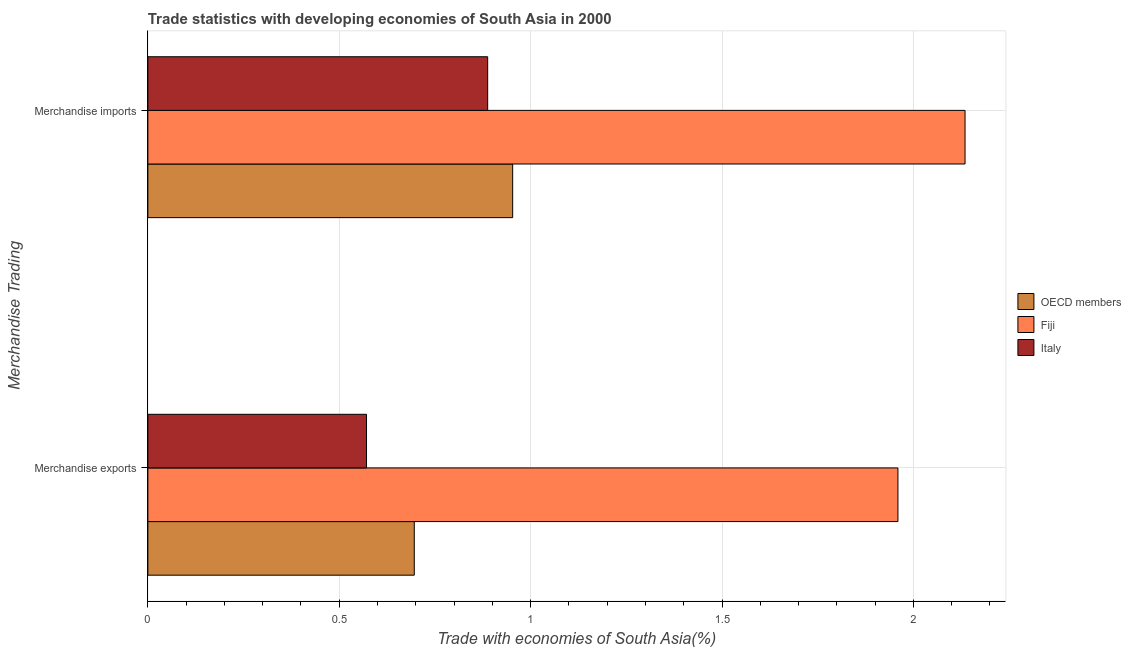How many groups of bars are there?
Give a very brief answer. 2. Are the number of bars per tick equal to the number of legend labels?
Give a very brief answer. Yes. Are the number of bars on each tick of the Y-axis equal?
Ensure brevity in your answer.  Yes. What is the label of the 2nd group of bars from the top?
Make the answer very short. Merchandise exports. What is the merchandise exports in Fiji?
Ensure brevity in your answer.  1.96. Across all countries, what is the maximum merchandise imports?
Offer a terse response. 2.13. Across all countries, what is the minimum merchandise exports?
Offer a very short reply. 0.57. In which country was the merchandise imports maximum?
Provide a succinct answer. Fiji. In which country was the merchandise imports minimum?
Provide a succinct answer. Italy. What is the total merchandise imports in the graph?
Your response must be concise. 3.98. What is the difference between the merchandise imports in Italy and that in Fiji?
Offer a very short reply. -1.25. What is the difference between the merchandise exports in Italy and the merchandise imports in Fiji?
Keep it short and to the point. -1.56. What is the average merchandise exports per country?
Your answer should be very brief. 1.08. What is the difference between the merchandise imports and merchandise exports in Italy?
Your answer should be compact. 0.32. What is the ratio of the merchandise exports in OECD members to that in Fiji?
Your response must be concise. 0.36. Is the merchandise imports in Italy less than that in Fiji?
Offer a very short reply. Yes. In how many countries, is the merchandise imports greater than the average merchandise imports taken over all countries?
Your response must be concise. 1. What does the 1st bar from the bottom in Merchandise imports represents?
Make the answer very short. OECD members. How many countries are there in the graph?
Ensure brevity in your answer.  3. What is the difference between two consecutive major ticks on the X-axis?
Offer a terse response. 0.5. Are the values on the major ticks of X-axis written in scientific E-notation?
Ensure brevity in your answer.  No. Does the graph contain any zero values?
Keep it short and to the point. No. Does the graph contain grids?
Make the answer very short. Yes. Where does the legend appear in the graph?
Ensure brevity in your answer.  Center right. How many legend labels are there?
Your answer should be very brief. 3. What is the title of the graph?
Your answer should be compact. Trade statistics with developing economies of South Asia in 2000. Does "Mozambique" appear as one of the legend labels in the graph?
Your answer should be very brief. No. What is the label or title of the X-axis?
Give a very brief answer. Trade with economies of South Asia(%). What is the label or title of the Y-axis?
Provide a succinct answer. Merchandise Trading. What is the Trade with economies of South Asia(%) in OECD members in Merchandise exports?
Give a very brief answer. 0.7. What is the Trade with economies of South Asia(%) of Fiji in Merchandise exports?
Give a very brief answer. 1.96. What is the Trade with economies of South Asia(%) of Italy in Merchandise exports?
Your answer should be compact. 0.57. What is the Trade with economies of South Asia(%) in OECD members in Merchandise imports?
Your response must be concise. 0.95. What is the Trade with economies of South Asia(%) of Fiji in Merchandise imports?
Keep it short and to the point. 2.13. What is the Trade with economies of South Asia(%) in Italy in Merchandise imports?
Provide a short and direct response. 0.89. Across all Merchandise Trading, what is the maximum Trade with economies of South Asia(%) of OECD members?
Your answer should be compact. 0.95. Across all Merchandise Trading, what is the maximum Trade with economies of South Asia(%) in Fiji?
Offer a terse response. 2.13. Across all Merchandise Trading, what is the maximum Trade with economies of South Asia(%) in Italy?
Your answer should be very brief. 0.89. Across all Merchandise Trading, what is the minimum Trade with economies of South Asia(%) of OECD members?
Provide a short and direct response. 0.7. Across all Merchandise Trading, what is the minimum Trade with economies of South Asia(%) in Fiji?
Provide a succinct answer. 1.96. Across all Merchandise Trading, what is the minimum Trade with economies of South Asia(%) of Italy?
Make the answer very short. 0.57. What is the total Trade with economies of South Asia(%) of OECD members in the graph?
Make the answer very short. 1.65. What is the total Trade with economies of South Asia(%) in Fiji in the graph?
Give a very brief answer. 4.09. What is the total Trade with economies of South Asia(%) in Italy in the graph?
Offer a terse response. 1.46. What is the difference between the Trade with economies of South Asia(%) in OECD members in Merchandise exports and that in Merchandise imports?
Provide a succinct answer. -0.26. What is the difference between the Trade with economies of South Asia(%) of Fiji in Merchandise exports and that in Merchandise imports?
Your response must be concise. -0.18. What is the difference between the Trade with economies of South Asia(%) in Italy in Merchandise exports and that in Merchandise imports?
Ensure brevity in your answer.  -0.32. What is the difference between the Trade with economies of South Asia(%) of OECD members in Merchandise exports and the Trade with economies of South Asia(%) of Fiji in Merchandise imports?
Offer a terse response. -1.44. What is the difference between the Trade with economies of South Asia(%) in OECD members in Merchandise exports and the Trade with economies of South Asia(%) in Italy in Merchandise imports?
Ensure brevity in your answer.  -0.19. What is the difference between the Trade with economies of South Asia(%) of Fiji in Merchandise exports and the Trade with economies of South Asia(%) of Italy in Merchandise imports?
Ensure brevity in your answer.  1.07. What is the average Trade with economies of South Asia(%) in OECD members per Merchandise Trading?
Provide a short and direct response. 0.82. What is the average Trade with economies of South Asia(%) in Fiji per Merchandise Trading?
Provide a succinct answer. 2.05. What is the average Trade with economies of South Asia(%) in Italy per Merchandise Trading?
Your answer should be compact. 0.73. What is the difference between the Trade with economies of South Asia(%) of OECD members and Trade with economies of South Asia(%) of Fiji in Merchandise exports?
Provide a short and direct response. -1.26. What is the difference between the Trade with economies of South Asia(%) of OECD members and Trade with economies of South Asia(%) of Italy in Merchandise exports?
Make the answer very short. 0.12. What is the difference between the Trade with economies of South Asia(%) of Fiji and Trade with economies of South Asia(%) of Italy in Merchandise exports?
Give a very brief answer. 1.39. What is the difference between the Trade with economies of South Asia(%) in OECD members and Trade with economies of South Asia(%) in Fiji in Merchandise imports?
Your answer should be compact. -1.18. What is the difference between the Trade with economies of South Asia(%) in OECD members and Trade with economies of South Asia(%) in Italy in Merchandise imports?
Ensure brevity in your answer.  0.07. What is the difference between the Trade with economies of South Asia(%) in Fiji and Trade with economies of South Asia(%) in Italy in Merchandise imports?
Give a very brief answer. 1.25. What is the ratio of the Trade with economies of South Asia(%) of OECD members in Merchandise exports to that in Merchandise imports?
Your response must be concise. 0.73. What is the ratio of the Trade with economies of South Asia(%) of Fiji in Merchandise exports to that in Merchandise imports?
Provide a succinct answer. 0.92. What is the ratio of the Trade with economies of South Asia(%) of Italy in Merchandise exports to that in Merchandise imports?
Give a very brief answer. 0.64. What is the difference between the highest and the second highest Trade with economies of South Asia(%) in OECD members?
Offer a terse response. 0.26. What is the difference between the highest and the second highest Trade with economies of South Asia(%) of Fiji?
Offer a terse response. 0.18. What is the difference between the highest and the second highest Trade with economies of South Asia(%) of Italy?
Provide a succinct answer. 0.32. What is the difference between the highest and the lowest Trade with economies of South Asia(%) in OECD members?
Your response must be concise. 0.26. What is the difference between the highest and the lowest Trade with economies of South Asia(%) in Fiji?
Keep it short and to the point. 0.18. What is the difference between the highest and the lowest Trade with economies of South Asia(%) in Italy?
Provide a succinct answer. 0.32. 